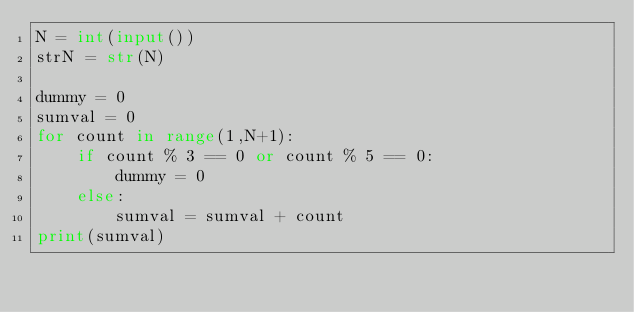Convert code to text. <code><loc_0><loc_0><loc_500><loc_500><_Python_>N = int(input())
strN = str(N)

dummy = 0
sumval = 0
for count in range(1,N+1):
    if count % 3 == 0 or count % 5 == 0:
        dummy = 0
    else:
        sumval = sumval + count
print(sumval)
       </code> 